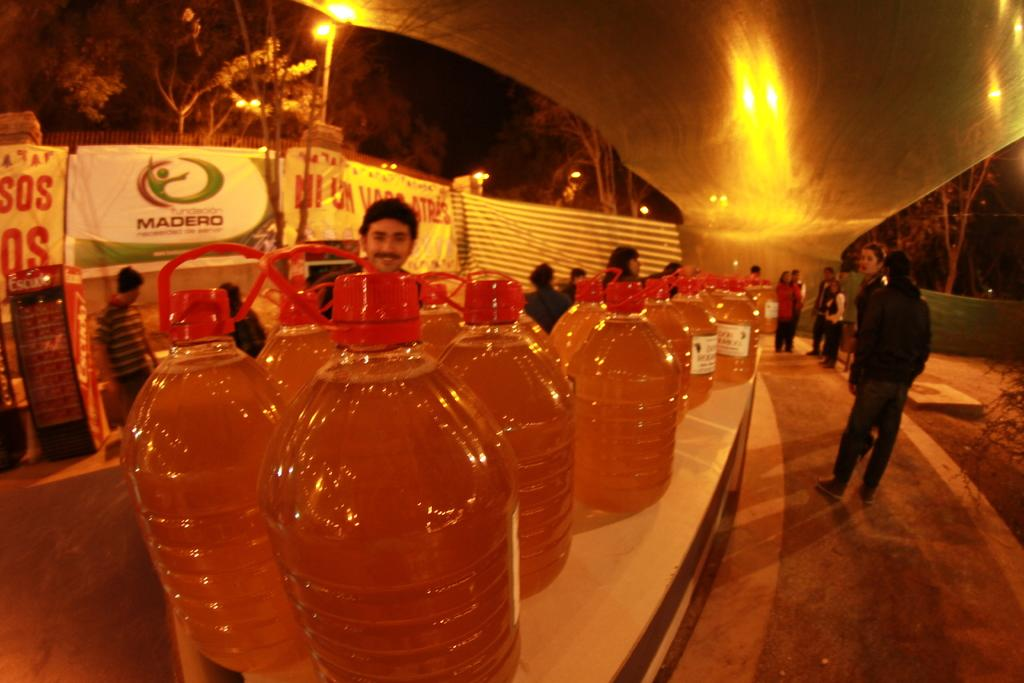Provide a one-sentence caption for the provided image. Table full of liquid containers with a "MADERO" ad in the background. 